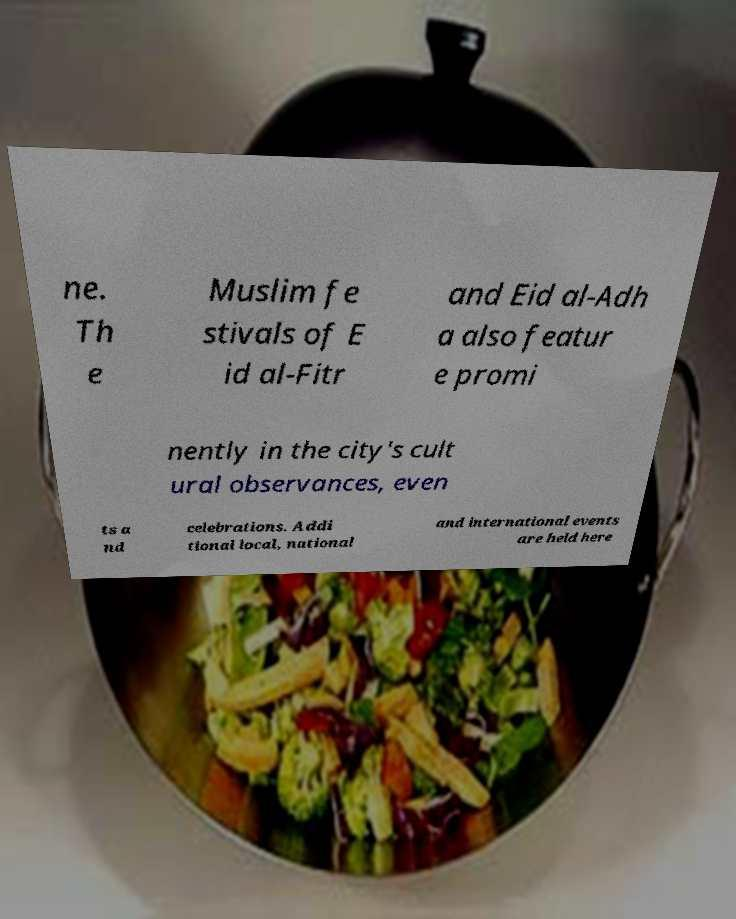What messages or text are displayed in this image? I need them in a readable, typed format. ne. Th e Muslim fe stivals of E id al-Fitr and Eid al-Adh a also featur e promi nently in the city's cult ural observances, even ts a nd celebrations. Addi tional local, national and international events are held here 